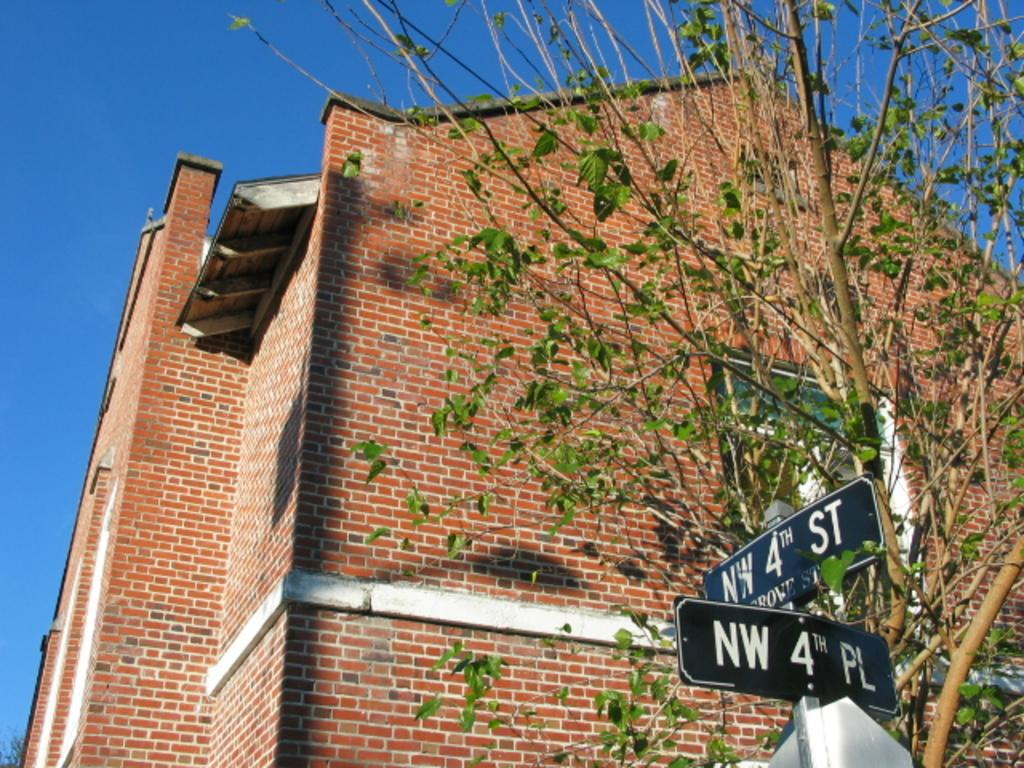<image>
Share a concise interpretation of the image provided. Street signs at the intersection of NW 4th Place and NW 4th Street 